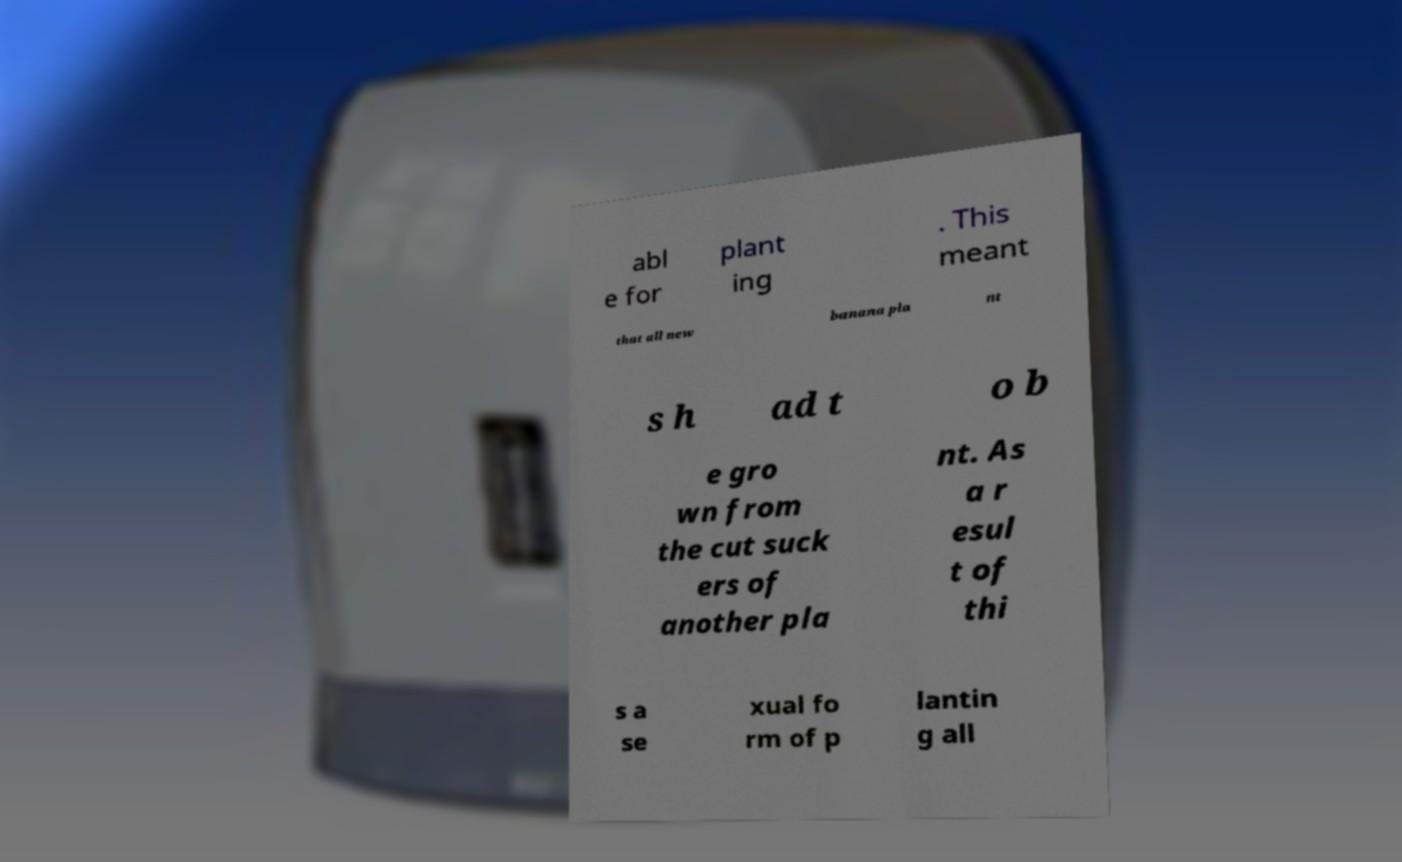Could you extract and type out the text from this image? abl e for plant ing . This meant that all new banana pla nt s h ad t o b e gro wn from the cut suck ers of another pla nt. As a r esul t of thi s a se xual fo rm of p lantin g all 